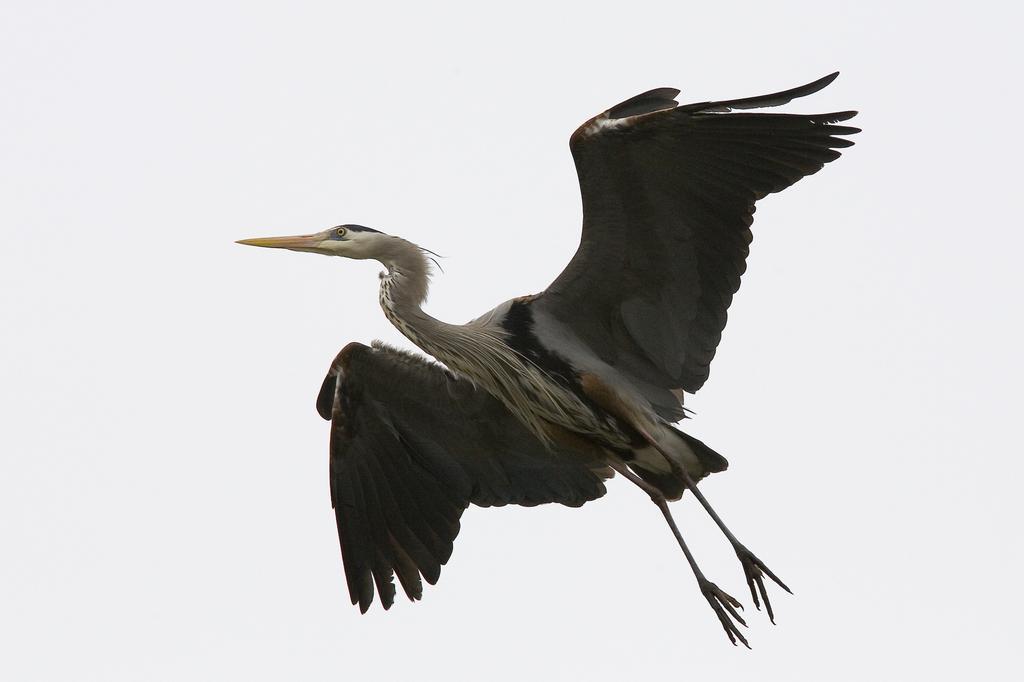In one or two sentences, can you explain what this image depicts? In this picture we can see heroin which is flying. On the back we can see sky and clouds. 